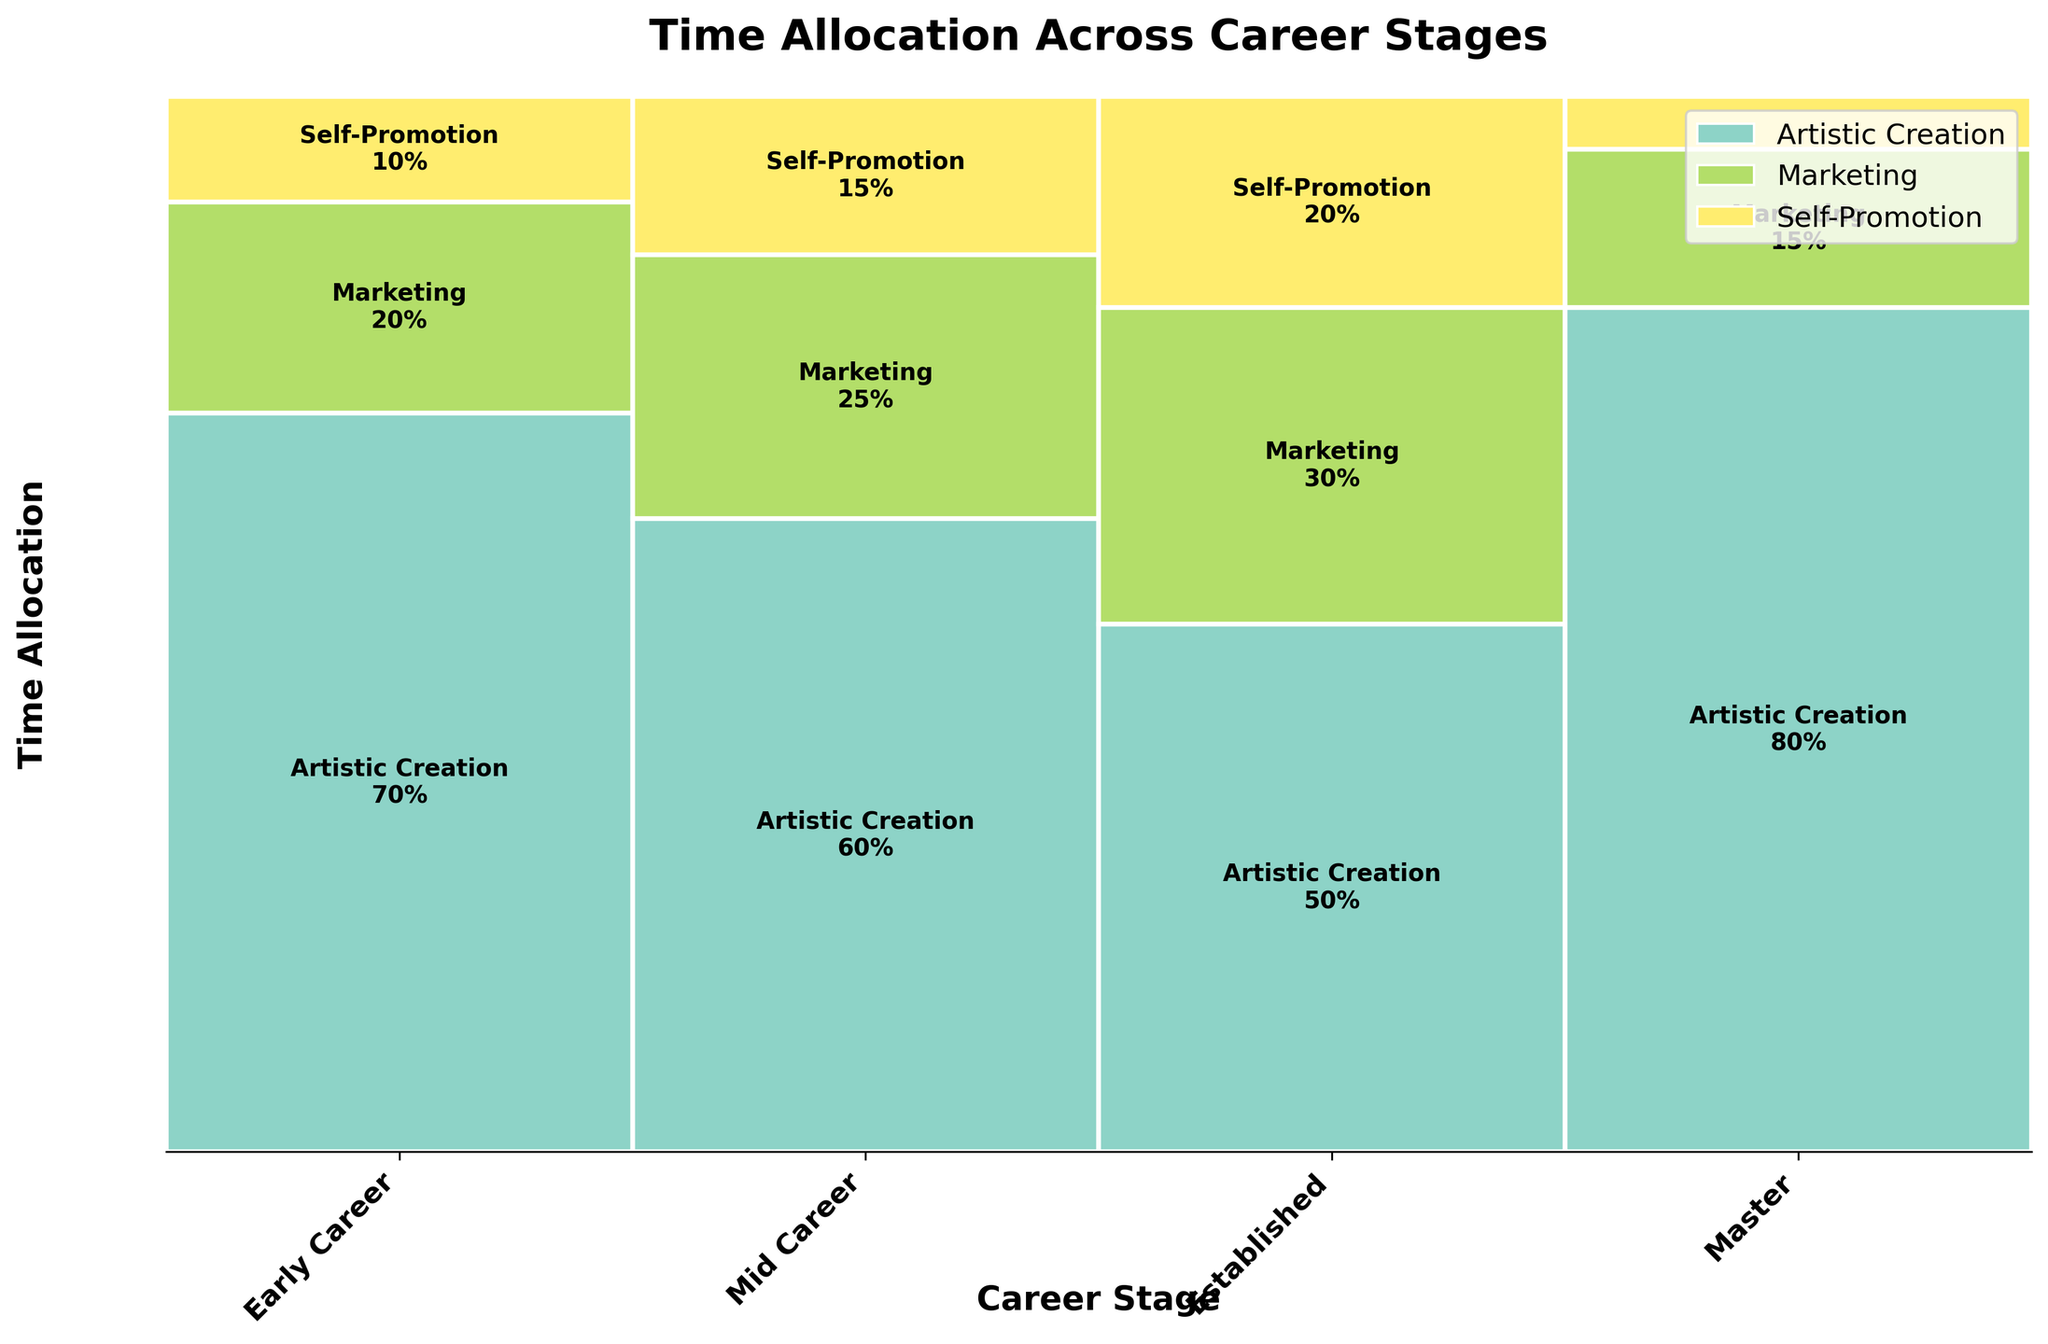How many career stages are represented in the plot? The plot title mentions "Career Stages," and the x-axis labels will show each career stage represented in the plot. Identify the unique labels on the x-axis to count the career stages.
Answer: Four Which activity has the highest percentage in the Master career stage? Locate the section labeled "Master" on the x-axis. Then, check the different sections of this career stage. The label with the highest percentage is the answer.
Answer: Artistic Creation What is the combined percentage of Marketing and Self-Promotion in the Early Career stage? Locate the "Early Career" section on the x-axis and add the percentages of Marketing (20%) and Self-Promotion (10%) shown in the rectangle labels.
Answer: 30% In which career stage is Self-Promotion the lowest? For each career stage on the x-axis, compare the height of the Self-Promotion section. The shortest section indicates the lowest percentage.
Answer: Master How does the time allocation for Artistic Creation change from Early Career to Established? Compare the height of the Artistic Creation rectangles for the Early Career (70%) and Established (50%) stages. Calculate the change in percentage.
Answer: Decreases by 20% Which career stage allocates the most time to Marketing? Compare the height of the Marketing rectangles across all career stages to find the tallest one.
Answer: Established Does the percentage of time spent on Self-Promotion ever exceed the time spent on Marketing in any career stage? Compare the rectangles for Marketing and Self-Promotion in each career stage. Check if the Self-Promotion percentage is larger than the Marketing percentage in any stage.
Answer: No What portion of the figure is devoted to non-Artistic Creation activities in the Mid Career stage? Subtract the Artistic Creation percentage in Mid Career (60%) from 100%. The remaining portion represents non-Artistic Creation activities.
Answer: 40% Which career stage has the largest combined percentage for non-Artistic Creation activities? For each career stage, sum the percentages of Marketing and Self-Promotion, then identify the career stage with the highest total.
Answer: Established How does the distribution of time allocation in the Master stage compare to the other stages? Observe the heights of Artistic Creation, Marketing, and Self-Promotion rectangles in the Master stage and compare these with the corresponding rectangles in other stages. The Master stage has significantly higher Artistic Creation and lower Self-Promotion and Marketing percentages.
Answer: More time on Artistic Creation, less on Marketing and Self-Promotion 